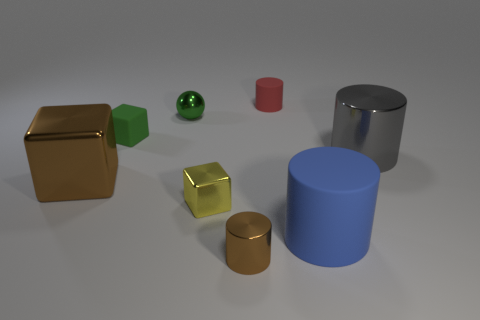What color is the cylinder behind the metallic cylinder that is behind the brown cylinder?
Provide a succinct answer. Red. What is the material of the small green thing that is the same shape as the yellow object?
Offer a very short reply. Rubber. What color is the metallic cylinder that is to the right of the rubber cylinder that is in front of the tiny cylinder behind the small green metal ball?
Provide a succinct answer. Gray. What number of objects are either small red cylinders or green metal objects?
Give a very brief answer. 2. How many large brown objects have the same shape as the large gray metallic object?
Keep it short and to the point. 0. Do the tiny red cylinder and the small cylinder in front of the small yellow cube have the same material?
Offer a very short reply. No. There is a green block that is made of the same material as the small red thing; what size is it?
Make the answer very short. Small. There is a cylinder to the right of the big blue cylinder; what is its size?
Offer a very short reply. Large. How many purple metallic balls have the same size as the green block?
Your answer should be very brief. 0. What is the size of the matte object that is the same color as the small ball?
Your answer should be very brief. Small. 